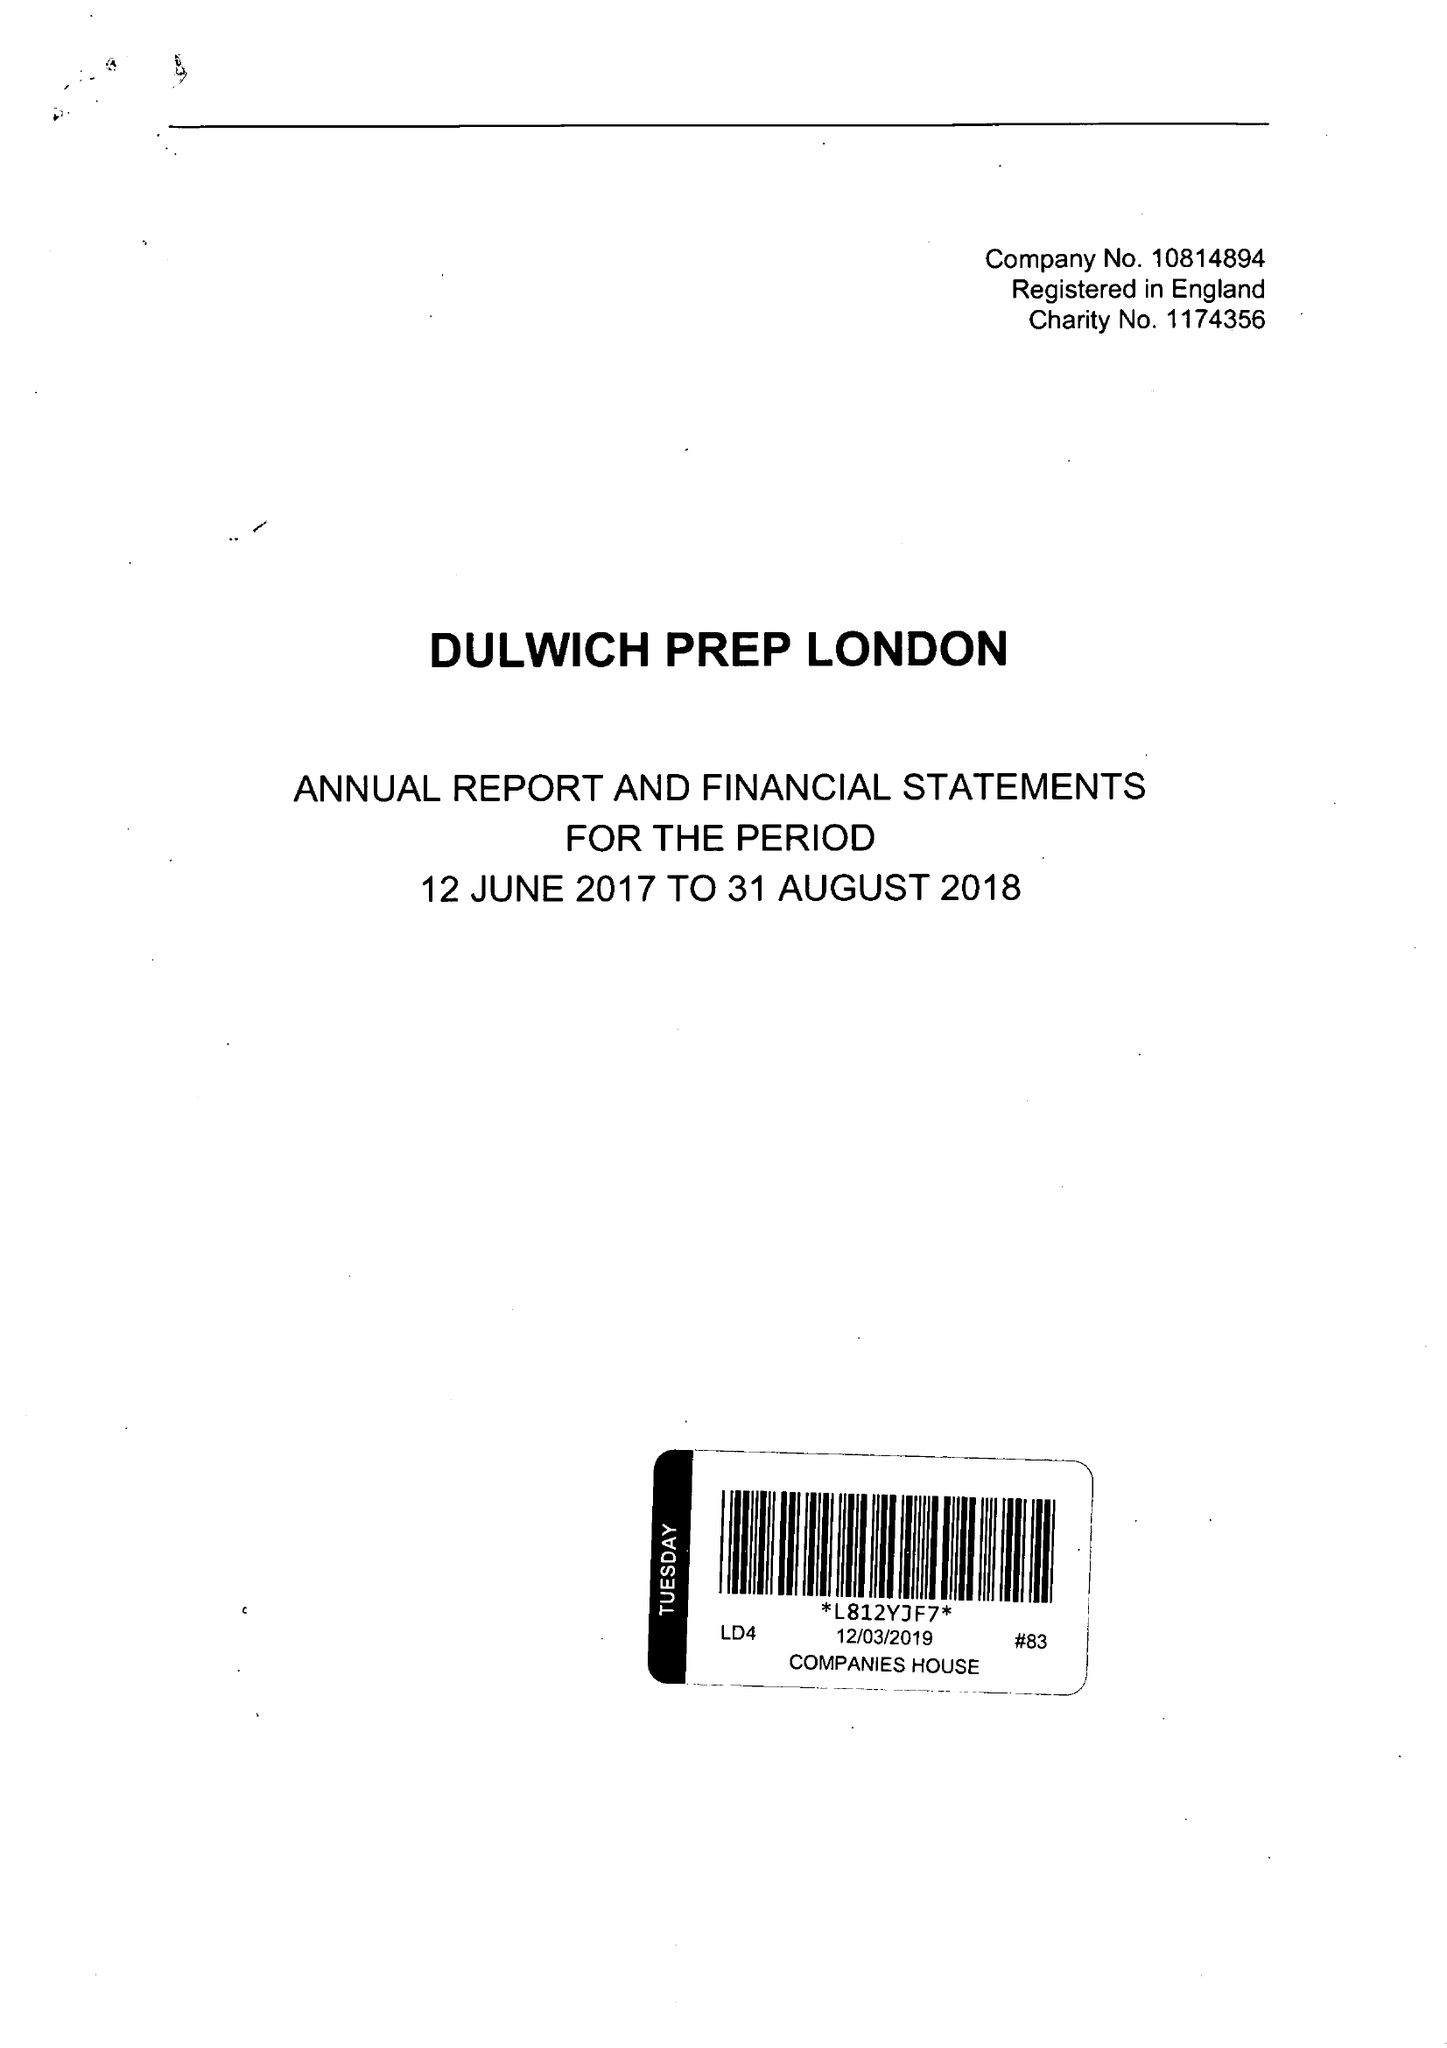What is the value for the address__postcode?
Answer the question using a single word or phrase. SE21 7AA 